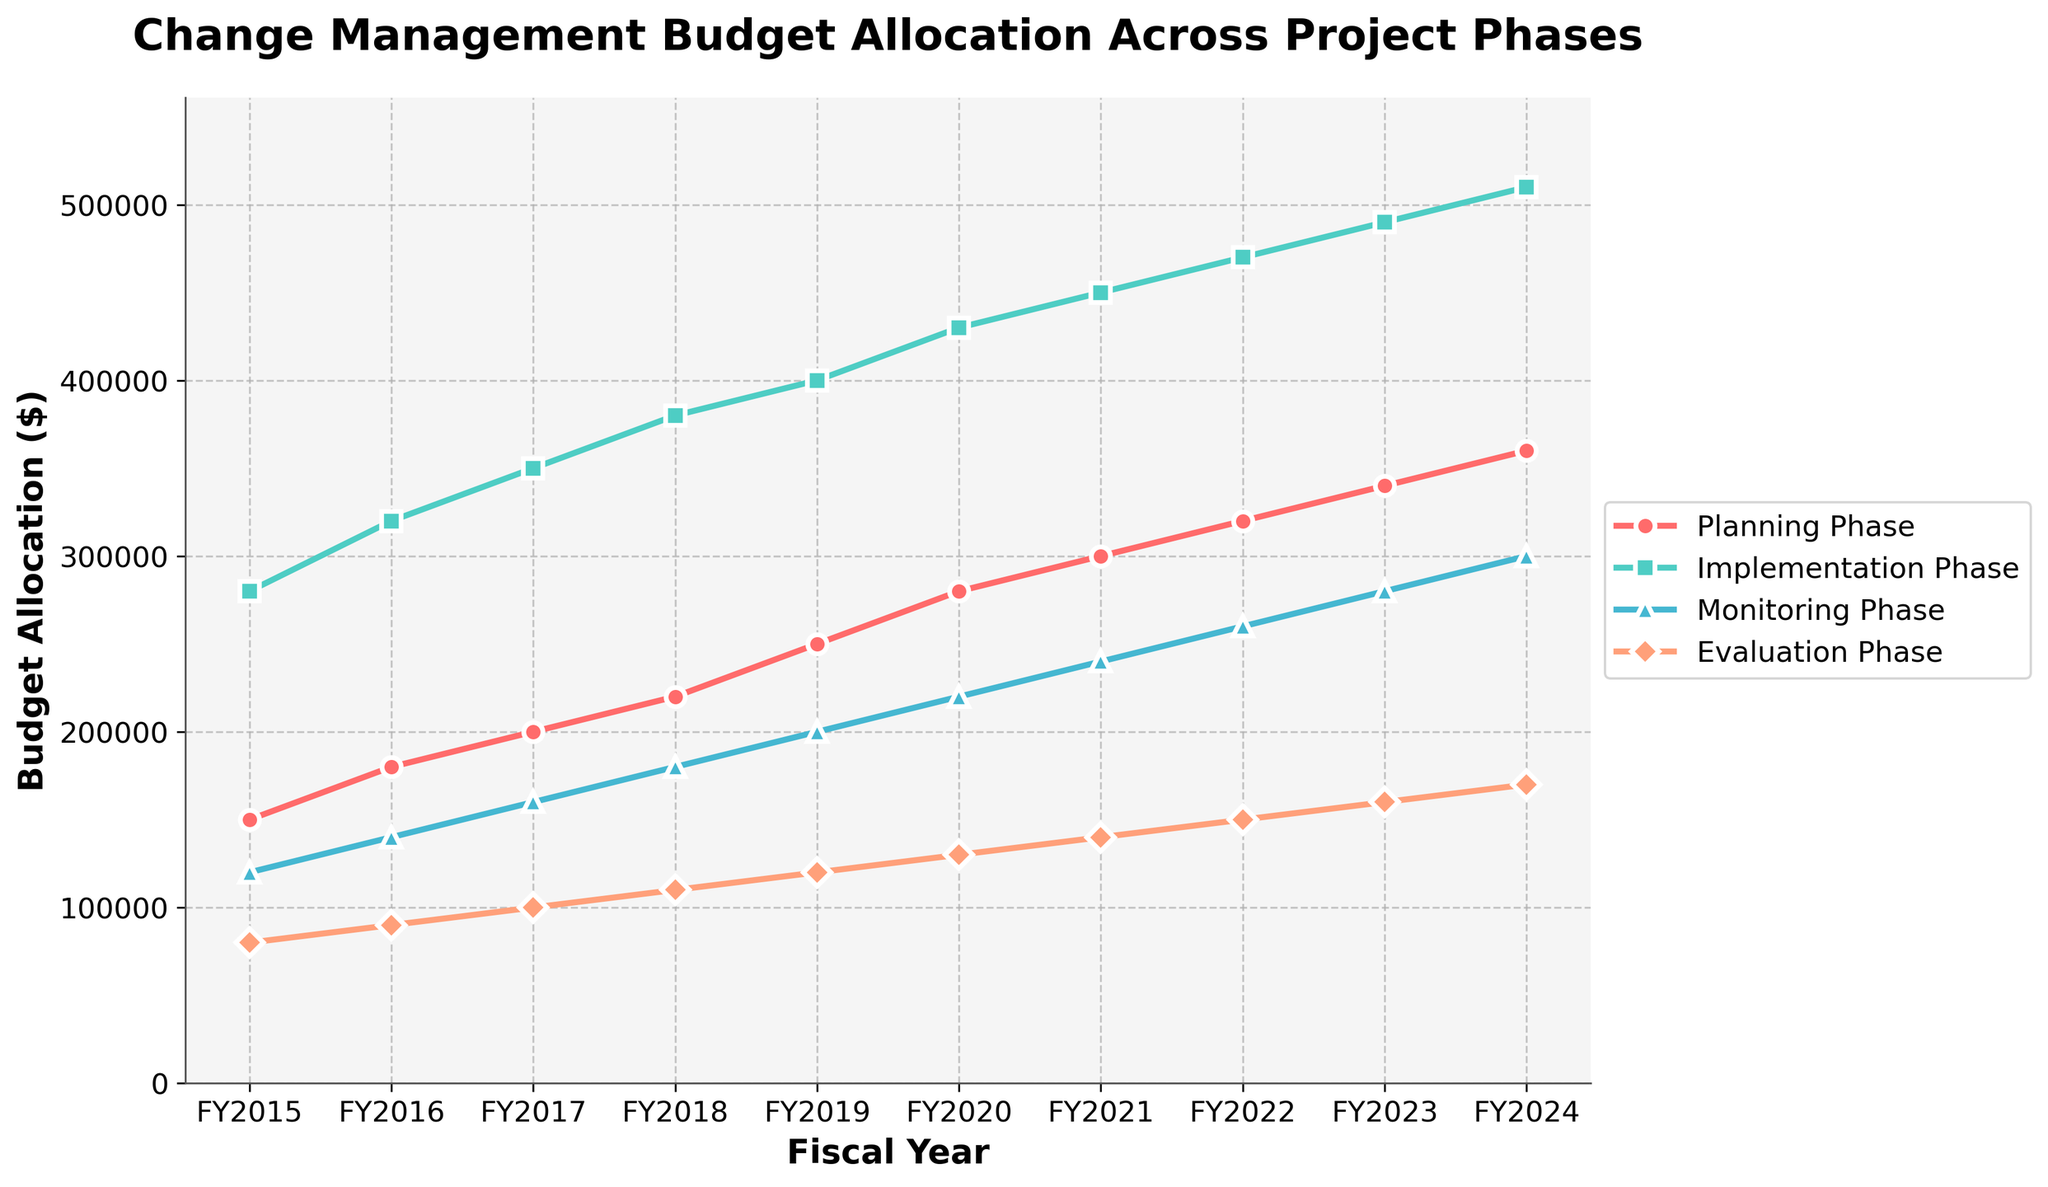What is the overall trend in budget allocation for the Implementation Phase from FY2015 to FY2024? Looking at the line representing the Implementation Phase, the plot shows a steady increase in budget allocation each fiscal year from FY2015 to FY2024.
Answer: It is increasing How much more budget was allocated to the Planning Phase in FY2024 compared to FY2015? To determine this, subtract the Planning Phase budget for FY2015 from the budget for FY2024. This results in 360,000 - 150,000.
Answer: 210,000 Which phase has the highest budget allocation in FY2023? By visually examining the plot for FY2023, it is clear that the line for the Implementation Phase is at the highest point compared to the other phases.
Answer: Implementation Phase Between which consecutive fiscal years did the Evaluation Phase see the greatest increase in budget allocation? To find this, calculate the differences in Evaluation Phase budgets between consecutive years and compare them. The difference is greatest between FY2023 and FY2024 (170,000 - 160,000 = 10,000).
Answer: Between FY2023 and FY2024 What is the average budget allocation for the Monitoring Phase over the entire period? Sum the budget allocations for the Monitoring Phase from FY2015 to FY2024, then divide by the number of fiscal years. (120,000 + 140,000 + 160,000 + 180,000 + 200,000 + 220,000 + 240,000 + 260,000 + 280,000 + 300,000) / 10 = 2,200,000 / 10
Answer: 220,000 Which phase's budget allocation shows the least variability over the fiscal years? By examining the changes over the years, the Evaluation Phase shows the smallest variations in budget allocation, as its increases are more consistent and modest compared to the other phases.
Answer: Evaluation Phase What is the total budget allocation for all phases combined in FY2019? Sum the values for all phases in FY2019: 250,000 (Planning Phase) + 400,000 (Implementation Phase) + 200,000 (Monitoring Phase) + 120,000 (Evaluation Phase) = 970,000
Answer: 970,000 Compare the rate of increase in budget allocation for the Planning and Monitoring Phases between FY2020 and FY2024. Which phase had a higher rate of increase? Calculate the rate of increase for each phase:
- Planning Phase: (360,000 - 280,000) / 280,000 = 0.2857
- Monitoring Phase: (300,000 - 220,000) / 220,000 = 0.3636
The Monitoring Phase had a higher rate of increase.
Answer: Monitoring Phase What is the pattern observed in the Evaluation Phase budget allocation, and how does it compare to the pattern in the Planning Phase across the fiscal years? The Evaluation Phase budget shows a steady increase each year, similarly to the Planning Phase. However, the rate of increase for the Evaluation Phase is consistent and smaller compared to the more substantial increments in the Planning Phase.
Answer: Steady but smaller increases compared to the Planning Phase 